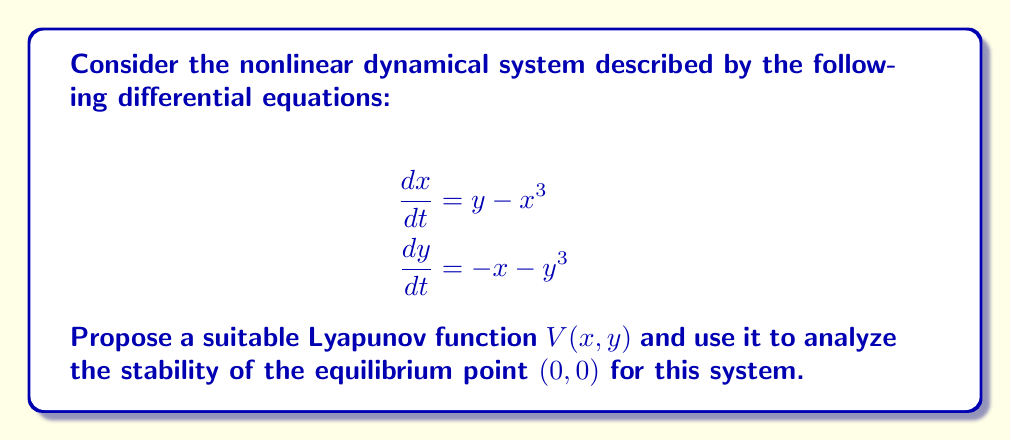What is the answer to this math problem? To analyze the stability of the nonlinear dynamical system, we'll follow these steps:

1) First, let's propose a Lyapunov function candidate:
   $$V(x,y) = \frac{1}{2}(x^2 + y^2)$$

2) We need to check if $V(x,y)$ is positive definite:
   $V(x,y) > 0$ for all $(x,y) \neq (0,0)$, and $V(0,0) = 0$
   This is clearly satisfied by our chosen function.

3) Now, we need to calculate $\frac{dV}{dt}$ along the trajectories of the system:

   $$\begin{align}
   \frac{dV}{dt} &= \frac{\partial V}{\partial x}\frac{dx}{dt} + \frac{\partial V}{\partial y}\frac{dy}{dt} \\
   &= x\frac{dx}{dt} + y\frac{dy}{dt} \\
   &= x(y - x^3) + y(-x - y^3) \\
   &= xy - x^4 - xy - y^4 \\
   &= -(x^4 + y^4)
   \end{align}$$

4) Analyze $\frac{dV}{dt}$:
   - $\frac{dV}{dt} < 0$ for all $(x,y) \neq (0,0)$
   - $\frac{dV}{dt} = 0$ only at $(0,0)$

5) Since $V(x,y)$ is positive definite and $\frac{dV}{dt}$ is negative definite, we can conclude that the equilibrium point $(0,0)$ is globally asymptotically stable according to Lyapunov's stability theorem.
Answer: The equilibrium point $(0,0)$ is globally asymptotically stable. 